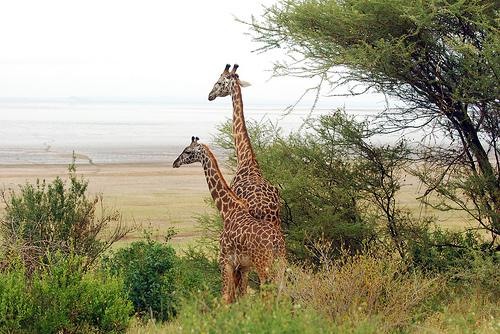Question: how does the water appear?
Choices:
A. Glassy.
B. Choppy.
C. Calm.
D. Murky.
Answer with the letter. Answer: C Question: where are these animals standing?
Choices:
A. In a field.
B. At the barn.
C. In the pasture.
D. In the cage.
Answer with the letter. Answer: A Question: when was this photo taken?
Choices:
A. Last week.
B. In the daytime.
C. Thursday.
D. Yesterday.
Answer with the letter. Answer: B Question: what kinds of animals are these?
Choices:
A. Giraffes.
B. Frogs.
C. Dogs.
D. Cats.
Answer with the letter. Answer: A Question: how does the sky appear?
Choices:
A. Clear.
B. Foggy.
C. Cloudy.
D. Sunny.
Answer with the letter. Answer: A Question: what is in the background?
Choices:
A. The ocean.
B. A body of water.
C. The mountains.
D. The carnival.
Answer with the letter. Answer: B 